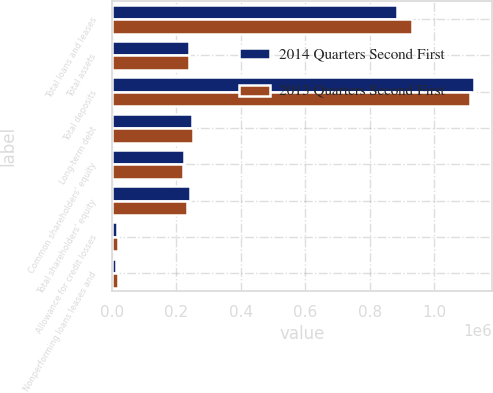Convert chart to OTSL. <chart><loc_0><loc_0><loc_500><loc_500><stacked_bar_chart><ecel><fcel>Total loans and leases<fcel>Total assets<fcel>Total deposits<fcel>Long-term debt<fcel>Common shareholders' equity<fcel>Total shareholders' equity<fcel>Allowance for credit losses<fcel>Nonperforming loans leases and<nl><fcel>2014 Quarters Second First<fcel>884733<fcel>238432<fcel>1.12251e+06<fcel>249221<fcel>224473<fcel>243448<fcel>14947<fcel>12629<nl><fcel>2013 Quarters Second First<fcel>929777<fcel>238432<fcel>1.11267e+06<fcel>251055<fcel>220088<fcel>233415<fcel>17912<fcel>17772<nl></chart> 